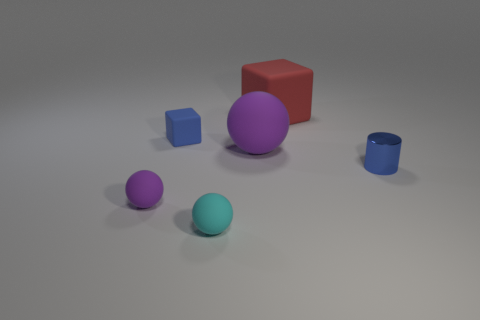Add 1 large purple rubber things. How many objects exist? 7 Subtract all blocks. How many objects are left? 4 Subtract 0 brown cubes. How many objects are left? 6 Subtract all large blocks. Subtract all purple objects. How many objects are left? 3 Add 6 small cyan matte spheres. How many small cyan matte spheres are left? 7 Add 2 tiny cyan rubber things. How many tiny cyan rubber things exist? 3 